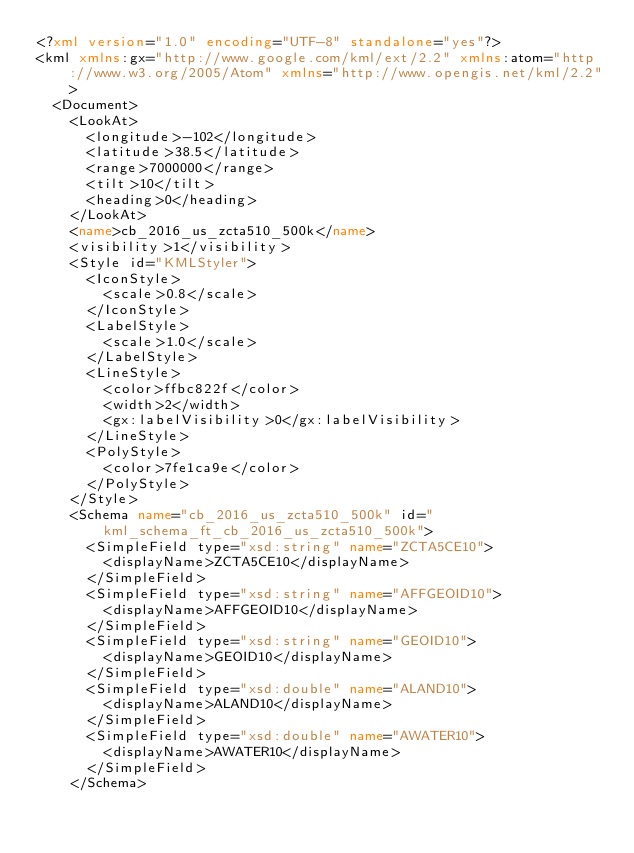Convert code to text. <code><loc_0><loc_0><loc_500><loc_500><_XML_><?xml version="1.0" encoding="UTF-8" standalone="yes"?>
<kml xmlns:gx="http://www.google.com/kml/ext/2.2" xmlns:atom="http://www.w3.org/2005/Atom" xmlns="http://www.opengis.net/kml/2.2">
  <Document>
    <LookAt>
      <longitude>-102</longitude>
      <latitude>38.5</latitude>
      <range>7000000</range>
      <tilt>10</tilt>
      <heading>0</heading>
    </LookAt>
    <name>cb_2016_us_zcta510_500k</name>
    <visibility>1</visibility>
    <Style id="KMLStyler">
      <IconStyle>
        <scale>0.8</scale>
      </IconStyle>
      <LabelStyle>
        <scale>1.0</scale>
      </LabelStyle>
      <LineStyle>
        <color>ffbc822f</color>
        <width>2</width>
        <gx:labelVisibility>0</gx:labelVisibility>
      </LineStyle>
      <PolyStyle>
        <color>7fe1ca9e</color>
      </PolyStyle>
    </Style>
    <Schema name="cb_2016_us_zcta510_500k" id="kml_schema_ft_cb_2016_us_zcta510_500k">
      <SimpleField type="xsd:string" name="ZCTA5CE10">
        <displayName>ZCTA5CE10</displayName>
      </SimpleField>
      <SimpleField type="xsd:string" name="AFFGEOID10">
        <displayName>AFFGEOID10</displayName>
      </SimpleField>
      <SimpleField type="xsd:string" name="GEOID10">
        <displayName>GEOID10</displayName>
      </SimpleField>
      <SimpleField type="xsd:double" name="ALAND10">
        <displayName>ALAND10</displayName>
      </SimpleField>
      <SimpleField type="xsd:double" name="AWATER10">
        <displayName>AWATER10</displayName>
      </SimpleField>
    </Schema></code> 